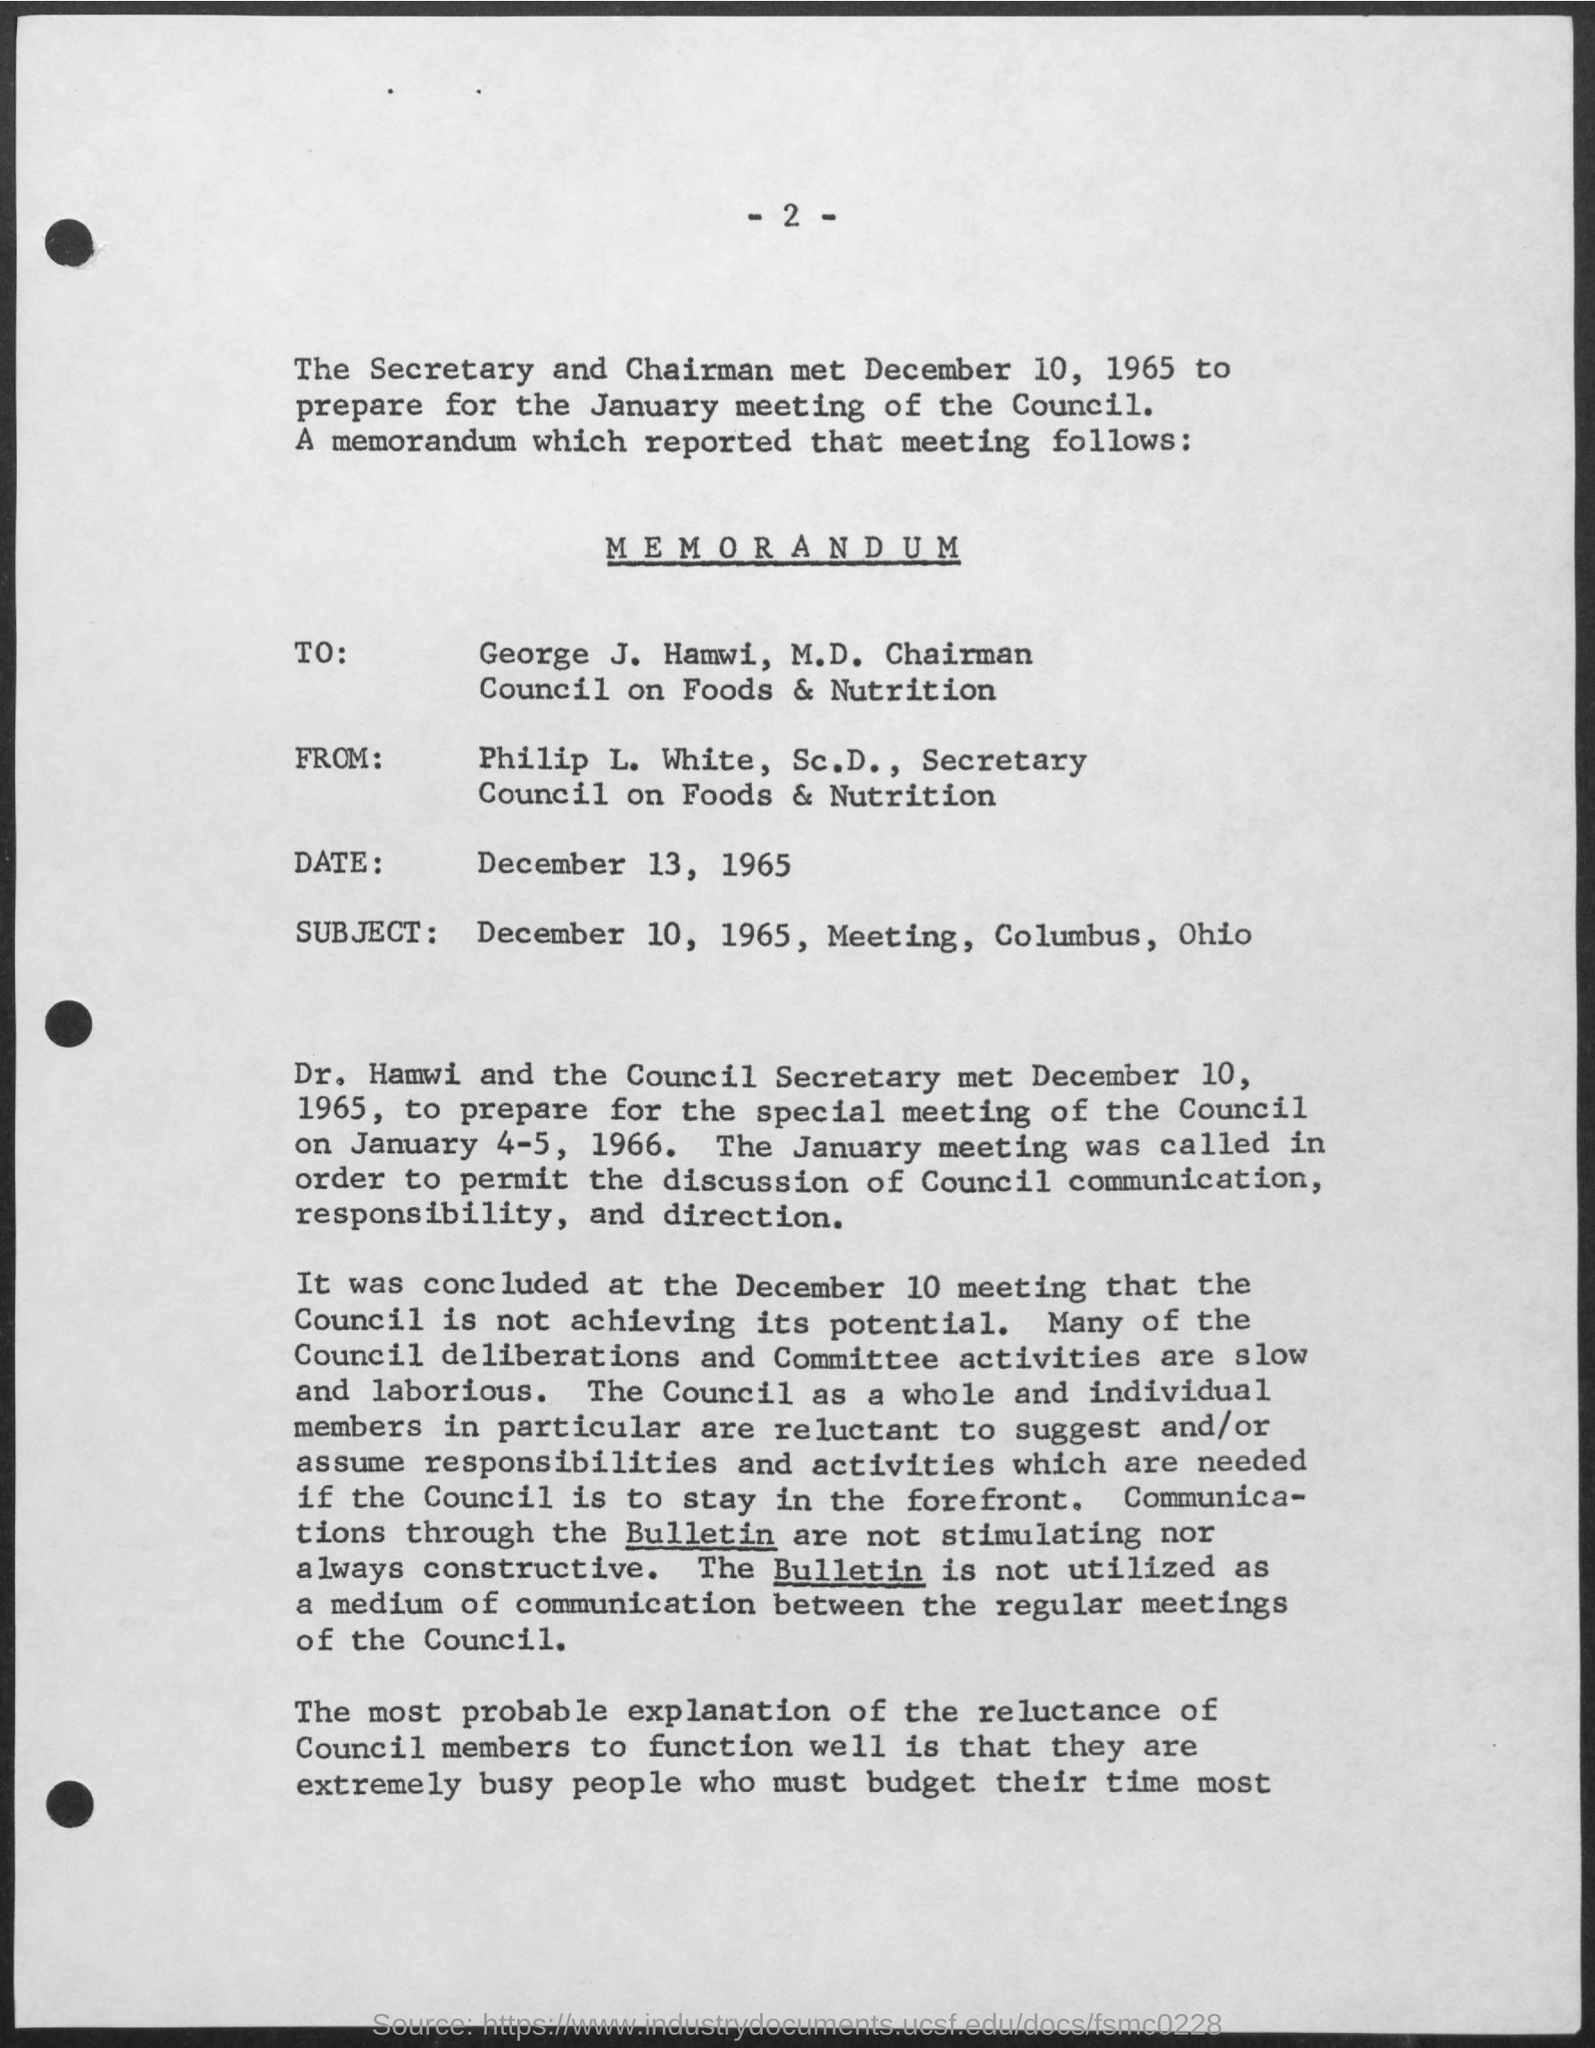Identify some key points in this picture. The memorandum was written to George J. Hamwi. The memorandum was received from Philip L. White. The memorandum mentions that George J. Hamwi is designated as the chairman. Philip L. White is referred to as the Secretary in the given memorandum. The date mentioned in the given memorandum is December 13, 1965. 